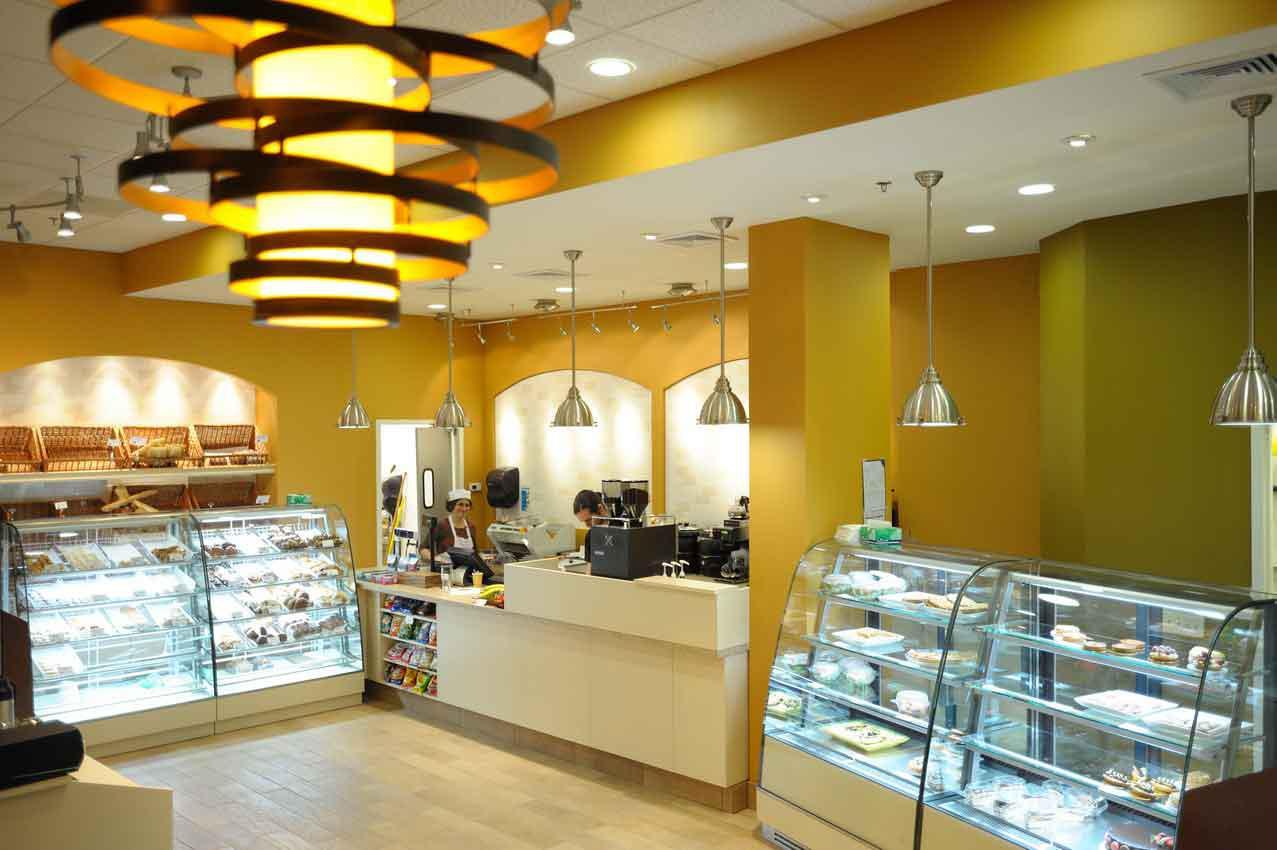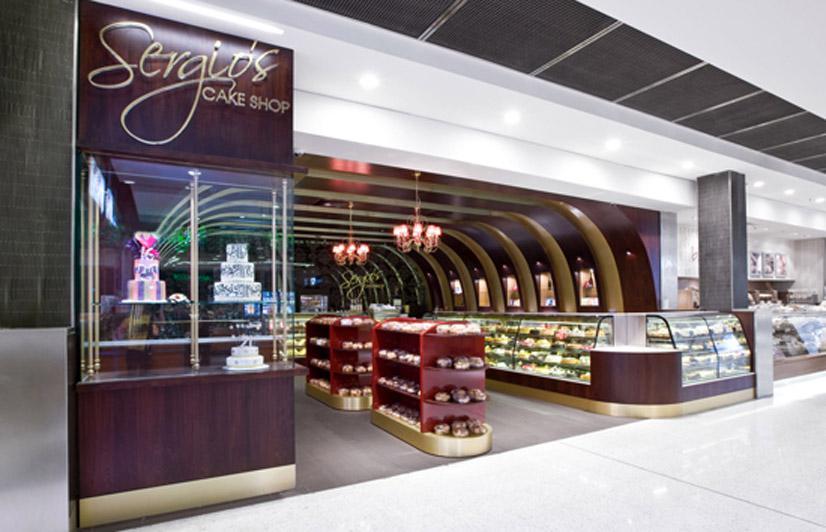The first image is the image on the left, the second image is the image on the right. Evaluate the accuracy of this statement regarding the images: "The decor of one bakery features a colorful suspended light with a round shape.". Is it true? Answer yes or no. Yes. The first image is the image on the left, the second image is the image on the right. For the images shown, is this caption "A bakery in one image has a seating area with tables and chairs where patrons can sit and enjoy the food and drinks they buy." true? Answer yes or no. No. 